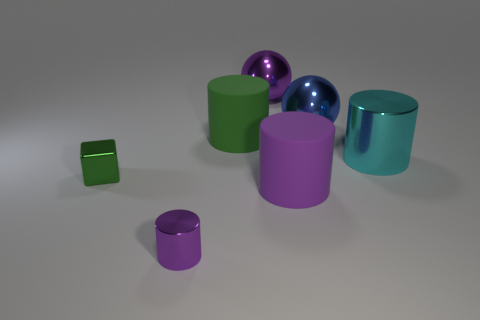Subtract all gray cylinders. Subtract all green cubes. How many cylinders are left? 4 Add 1 small purple things. How many objects exist? 8 Subtract all blocks. How many objects are left? 6 Add 1 large blue metal things. How many large blue metal things are left? 2 Add 7 big brown shiny spheres. How many big brown shiny spheres exist? 7 Subtract 0 yellow cylinders. How many objects are left? 7 Subtract all purple objects. Subtract all big blue balls. How many objects are left? 3 